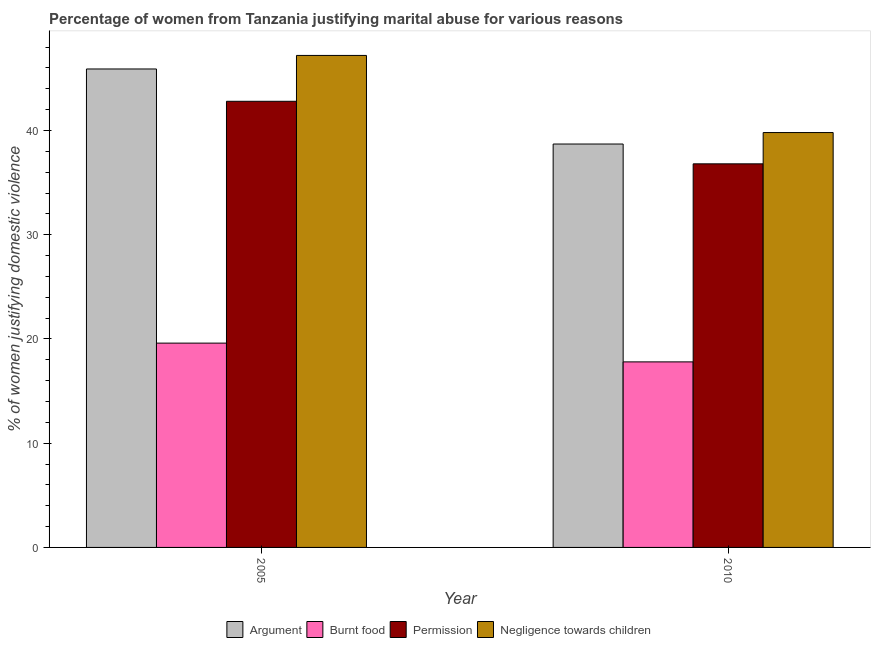How many different coloured bars are there?
Provide a short and direct response. 4. How many groups of bars are there?
Keep it short and to the point. 2. Are the number of bars per tick equal to the number of legend labels?
Ensure brevity in your answer.  Yes. Are the number of bars on each tick of the X-axis equal?
Keep it short and to the point. Yes. How many bars are there on the 1st tick from the left?
Offer a terse response. 4. How many bars are there on the 2nd tick from the right?
Provide a succinct answer. 4. What is the percentage of women justifying abuse for showing negligence towards children in 2010?
Provide a short and direct response. 39.8. Across all years, what is the maximum percentage of women justifying abuse for showing negligence towards children?
Offer a terse response. 47.2. Across all years, what is the minimum percentage of women justifying abuse in the case of an argument?
Your response must be concise. 38.7. In which year was the percentage of women justifying abuse in the case of an argument minimum?
Offer a terse response. 2010. What is the total percentage of women justifying abuse for going without permission in the graph?
Provide a short and direct response. 79.6. What is the difference between the percentage of women justifying abuse for burning food in 2005 and that in 2010?
Give a very brief answer. 1.8. What is the difference between the percentage of women justifying abuse in the case of an argument in 2005 and the percentage of women justifying abuse for burning food in 2010?
Your answer should be compact. 7.2. What is the average percentage of women justifying abuse for showing negligence towards children per year?
Provide a succinct answer. 43.5. What is the ratio of the percentage of women justifying abuse in the case of an argument in 2005 to that in 2010?
Your response must be concise. 1.19. Is the percentage of women justifying abuse in the case of an argument in 2005 less than that in 2010?
Offer a very short reply. No. In how many years, is the percentage of women justifying abuse for burning food greater than the average percentage of women justifying abuse for burning food taken over all years?
Your response must be concise. 1. What does the 3rd bar from the left in 2005 represents?
Your answer should be very brief. Permission. What does the 1st bar from the right in 2010 represents?
Provide a short and direct response. Negligence towards children. Is it the case that in every year, the sum of the percentage of women justifying abuse in the case of an argument and percentage of women justifying abuse for burning food is greater than the percentage of women justifying abuse for going without permission?
Offer a very short reply. Yes. How many bars are there?
Your response must be concise. 8. How many years are there in the graph?
Give a very brief answer. 2. Does the graph contain grids?
Ensure brevity in your answer.  No. How many legend labels are there?
Provide a short and direct response. 4. How are the legend labels stacked?
Offer a very short reply. Horizontal. What is the title of the graph?
Give a very brief answer. Percentage of women from Tanzania justifying marital abuse for various reasons. What is the label or title of the X-axis?
Make the answer very short. Year. What is the label or title of the Y-axis?
Give a very brief answer. % of women justifying domestic violence. What is the % of women justifying domestic violence of Argument in 2005?
Provide a succinct answer. 45.9. What is the % of women justifying domestic violence of Burnt food in 2005?
Provide a succinct answer. 19.6. What is the % of women justifying domestic violence in Permission in 2005?
Your answer should be compact. 42.8. What is the % of women justifying domestic violence in Negligence towards children in 2005?
Offer a very short reply. 47.2. What is the % of women justifying domestic violence in Argument in 2010?
Give a very brief answer. 38.7. What is the % of women justifying domestic violence in Permission in 2010?
Provide a succinct answer. 36.8. What is the % of women justifying domestic violence of Negligence towards children in 2010?
Make the answer very short. 39.8. Across all years, what is the maximum % of women justifying domestic violence of Argument?
Your answer should be compact. 45.9. Across all years, what is the maximum % of women justifying domestic violence of Burnt food?
Provide a short and direct response. 19.6. Across all years, what is the maximum % of women justifying domestic violence of Permission?
Your response must be concise. 42.8. Across all years, what is the maximum % of women justifying domestic violence of Negligence towards children?
Your response must be concise. 47.2. Across all years, what is the minimum % of women justifying domestic violence in Argument?
Offer a very short reply. 38.7. Across all years, what is the minimum % of women justifying domestic violence in Permission?
Make the answer very short. 36.8. Across all years, what is the minimum % of women justifying domestic violence of Negligence towards children?
Keep it short and to the point. 39.8. What is the total % of women justifying domestic violence in Argument in the graph?
Provide a short and direct response. 84.6. What is the total % of women justifying domestic violence of Burnt food in the graph?
Give a very brief answer. 37.4. What is the total % of women justifying domestic violence in Permission in the graph?
Provide a short and direct response. 79.6. What is the difference between the % of women justifying domestic violence in Burnt food in 2005 and that in 2010?
Ensure brevity in your answer.  1.8. What is the difference between the % of women justifying domestic violence of Permission in 2005 and that in 2010?
Your response must be concise. 6. What is the difference between the % of women justifying domestic violence in Negligence towards children in 2005 and that in 2010?
Provide a short and direct response. 7.4. What is the difference between the % of women justifying domestic violence in Argument in 2005 and the % of women justifying domestic violence in Burnt food in 2010?
Give a very brief answer. 28.1. What is the difference between the % of women justifying domestic violence in Argument in 2005 and the % of women justifying domestic violence in Permission in 2010?
Provide a succinct answer. 9.1. What is the difference between the % of women justifying domestic violence of Argument in 2005 and the % of women justifying domestic violence of Negligence towards children in 2010?
Offer a very short reply. 6.1. What is the difference between the % of women justifying domestic violence in Burnt food in 2005 and the % of women justifying domestic violence in Permission in 2010?
Your answer should be compact. -17.2. What is the difference between the % of women justifying domestic violence in Burnt food in 2005 and the % of women justifying domestic violence in Negligence towards children in 2010?
Offer a terse response. -20.2. What is the difference between the % of women justifying domestic violence in Permission in 2005 and the % of women justifying domestic violence in Negligence towards children in 2010?
Give a very brief answer. 3. What is the average % of women justifying domestic violence in Argument per year?
Provide a short and direct response. 42.3. What is the average % of women justifying domestic violence in Permission per year?
Provide a short and direct response. 39.8. What is the average % of women justifying domestic violence in Negligence towards children per year?
Offer a terse response. 43.5. In the year 2005, what is the difference between the % of women justifying domestic violence in Argument and % of women justifying domestic violence in Burnt food?
Ensure brevity in your answer.  26.3. In the year 2005, what is the difference between the % of women justifying domestic violence in Argument and % of women justifying domestic violence in Negligence towards children?
Your answer should be compact. -1.3. In the year 2005, what is the difference between the % of women justifying domestic violence of Burnt food and % of women justifying domestic violence of Permission?
Make the answer very short. -23.2. In the year 2005, what is the difference between the % of women justifying domestic violence of Burnt food and % of women justifying domestic violence of Negligence towards children?
Your answer should be compact. -27.6. In the year 2005, what is the difference between the % of women justifying domestic violence of Permission and % of women justifying domestic violence of Negligence towards children?
Offer a very short reply. -4.4. In the year 2010, what is the difference between the % of women justifying domestic violence in Argument and % of women justifying domestic violence in Burnt food?
Provide a succinct answer. 20.9. In the year 2010, what is the difference between the % of women justifying domestic violence in Argument and % of women justifying domestic violence in Permission?
Ensure brevity in your answer.  1.9. What is the ratio of the % of women justifying domestic violence in Argument in 2005 to that in 2010?
Your answer should be compact. 1.19. What is the ratio of the % of women justifying domestic violence in Burnt food in 2005 to that in 2010?
Offer a very short reply. 1.1. What is the ratio of the % of women justifying domestic violence of Permission in 2005 to that in 2010?
Keep it short and to the point. 1.16. What is the ratio of the % of women justifying domestic violence in Negligence towards children in 2005 to that in 2010?
Make the answer very short. 1.19. What is the difference between the highest and the second highest % of women justifying domestic violence of Argument?
Your answer should be very brief. 7.2. What is the difference between the highest and the lowest % of women justifying domestic violence of Argument?
Offer a terse response. 7.2. What is the difference between the highest and the lowest % of women justifying domestic violence of Burnt food?
Make the answer very short. 1.8. 